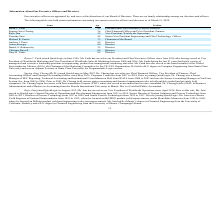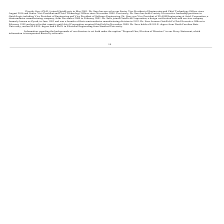From Quicklogic Corporation's financial document, What are the respective names of the company's President and Chief Financial Officer? The document shows two values: Brian C. Faith and Suping (Sue) Cheung. From the document: "Suping (Sue) Cheung 56 Chief Financial Officer and Vice President, Finance Brian C. Faith 45 President and Chief Executive Officer; Director..." Also, What are the respective names of the company's Vice President of Worldwide Operations and Chief Executive Officer? The document shows two values: Rajiv Jain and Brian C. Faith. From the document: "Brian C. Faith 45 President and Chief Executive Officer; Director Rajiv Jain 59 Vice President, Worldwide Operations..." Also, What are the respective names of the company's Chief Financial Officer and Vice President of Worldwide Operations? The document shows two values: Suping (Sue) Cheung and Rajiv Jain. From the document: "Rajiv Jain 59 Vice President, Worldwide Operations Suping (Sue) Cheung 56 Chief Financial Officer and Vice President, Finance..." Also, can you calculate: What is the average age of the company's President and Vice President of Worldwide Operations? To answer this question, I need to perform calculations using the financial data. The calculation is: (45 + 59)/2 , which equals 52. This is based on the information: "Brian C. Faith 45 President and Chief Executive Officer; Director Rajiv Jain 59 Vice President, Worldwide Operations..." The key data points involved are: 45, 59. Also, can you calculate: What is the average age of the company's President and Chief Financial Officer? To answer this question, I need to perform calculations using the financial data. The calculation is: (45 + 56)/2 , which equals 50.5. This is based on the information: "Suping (Sue) Cheung 56 Chief Financial Officer and Vice President, Finance Brian C. Faith 45 President and Chief Executive Officer; Director..." The key data points involved are: 45, 56. Also, can you calculate: What is the average age of the company's Vice President of Worldwide Operations and Chief Technology Officer? To answer this question, I need to perform calculations using the financial data. The calculation is: (59 + 64)/2 , which equals 61.5. This is based on the information: "Timothy Saxe 64 Senior Vice President Engineering and Chief Technology Officer Rajiv Jain 59 Vice President, Worldwide Operations..." The key data points involved are: 59, 64. 